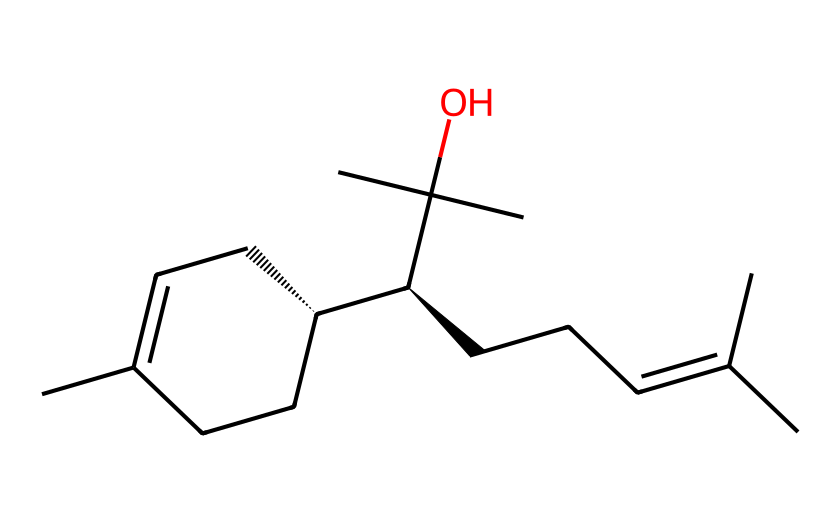What is the molecular formula of this compound? To determine the molecular formula, we count the number of each type of atom present in the SMILES representation. In this case, there are: 21 Carbon (C) atoms and 34 Hydrogen (H) atoms, leading to the formula C21H34.
Answer: C21H34 How many double bonds are present in this molecule? Looking at the SMILES representation, we can identify the presence of double bonds indicated by "=" symbols. There are four double bonds present in the structure.
Answer: 4 What is the IUPAC name of this aromatic compound? Based on the structure deduced from the SMILES representation, this compound can be classified and named systematically. Its IUPAC name is (E)-1,2,3,3-tetramethyl-2-(1-methylethenyl)-1-cyclopropanecarboxaldehyde.
Answer: (E)-1,2,3,3-tetramethyl-2-(1-methylethenyl)-1-cyclopropanecarboxaldehyde What does the presence of a hydroxyl group indicate about this compound? The hydroxyl group (-OH) in the SMILES representation suggests that this compound has alcohol functionality, which can imply it may have properties such as solubility in water or potential for hydrogen bonding.
Answer: alcohol How does the branching in this molecule affect its aroma profile? The branching in the carbon chain, as suggested by the structure, can influence the volatility and, ultimately, the aroma profile. Branching typically results in lower boiling points and can create more complex fragrances, making the scent more desirable.
Answer: influences aroma profile What type of aromatic system is indicated in this structure? The presence of an aromatic ring in the structure denotes that this compound belongs to the class of aromatic compounds known as phenolics, which often contribute to complex scents.
Answer: phenolic 